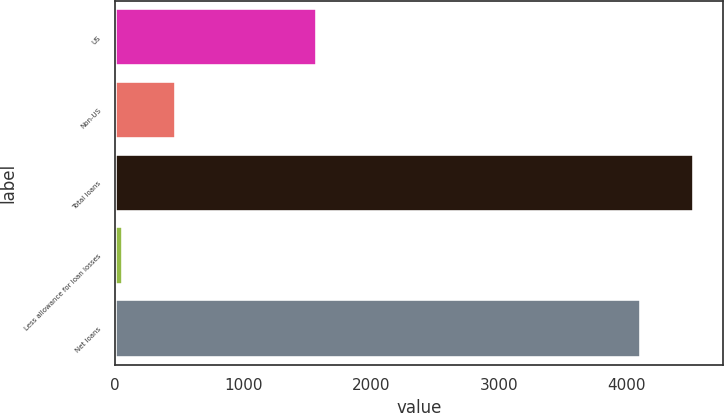<chart> <loc_0><loc_0><loc_500><loc_500><bar_chart><fcel>US<fcel>Non-US<fcel>Total loans<fcel>Less allowance for loan losses<fcel>Net loans<nl><fcel>1578<fcel>474<fcel>4524.3<fcel>61<fcel>4113<nl></chart> 